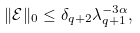<formula> <loc_0><loc_0><loc_500><loc_500>\| \mathcal { E } \| _ { 0 } \leq \delta _ { q + 2 } \lambda _ { q + 1 } ^ { - 3 \alpha } ,</formula> 